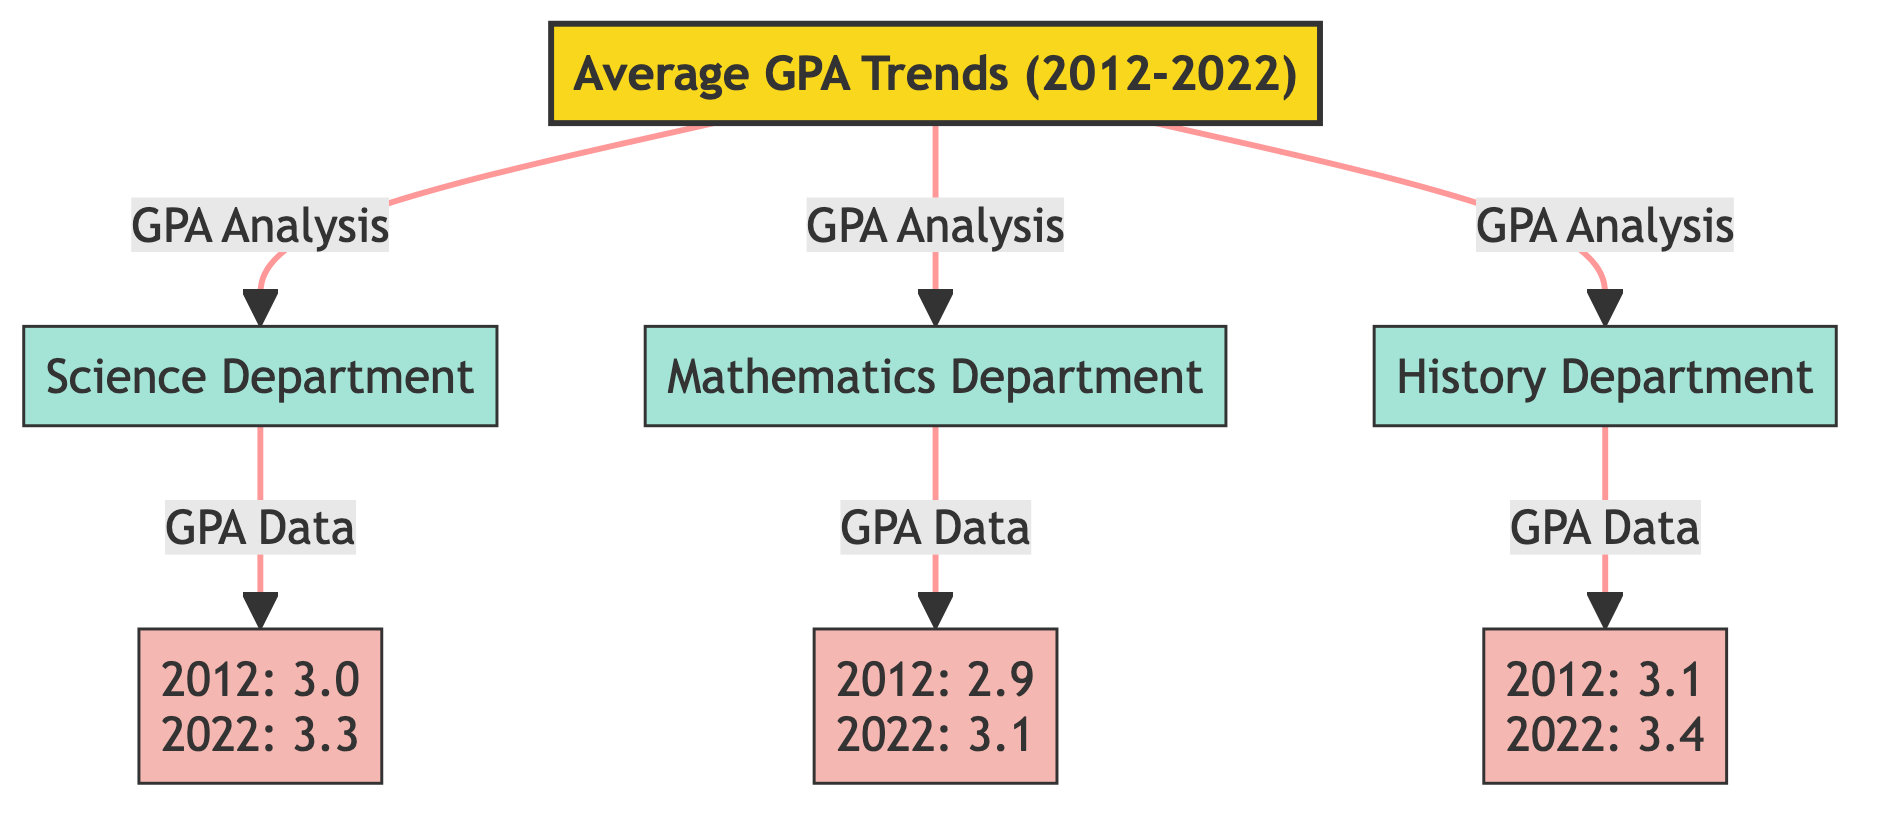What is the average GPA in the Science Department for the year 2022? The diagram specifies that the average GPA for the Science Department in 2022 is mentioned directly beneath the node labeled "GPA_Science". It states "2022: 3.3".
Answer: 3.3 What was the average GPA for the Mathematics Department in 2012? The average GPA for the Mathematics Department in 2012 is displayed below its corresponding node "GPA_Math". The text indicates "2012: 2.9".
Answer: 2.9 Which department showed the highest average GPA in 2022? By comparing the GPAs in 2022 from the nodes, the Science Department has an average GPA of 3.3, the Mathematics Department has 3.1, and the History Department has 3.4. The highest value is found in the History Department.
Answer: History Department How many departments are analyzed in this diagram? The diagram shows three departments, indicated by the respective nodes for the Science, Mathematics, and History Departments. Thus, the total is counted directly from these nodes.
Answer: 3 What is the trend of average GPA for the History Department from 2012 to 2022? By reviewing the information from the "GPA_History" node, it states that the average GPA for the History Department increased from 3.1 in 2012 to 3.4 in 2022. This indicates a positive trend.
Answer: Increased Which department had the lowest GPA in 2012? The data from the nodes indicates that the Science Department had a GPA of 3.0, the Mathematics Department had a GPA of 2.9, and the History Department had a GPA of 3.1 in 2012. The lowest value is in the Mathematics Department.
Answer: Mathematics Department What color represents the departments in the diagram? The style of the department nodes is assigned to be filled with a specific shade. The color used for department classification in the diagram is #a3e4d7.
Answer: #a3e4d7 Where can the average GPA data be found in the diagram? The average GPA data for each department is shown in specific nodes linked directly from each department node. The nodes are labeled as "GPA_Science", "GPA_Math", and "GPA_History".
Answer: Beneath each department node 